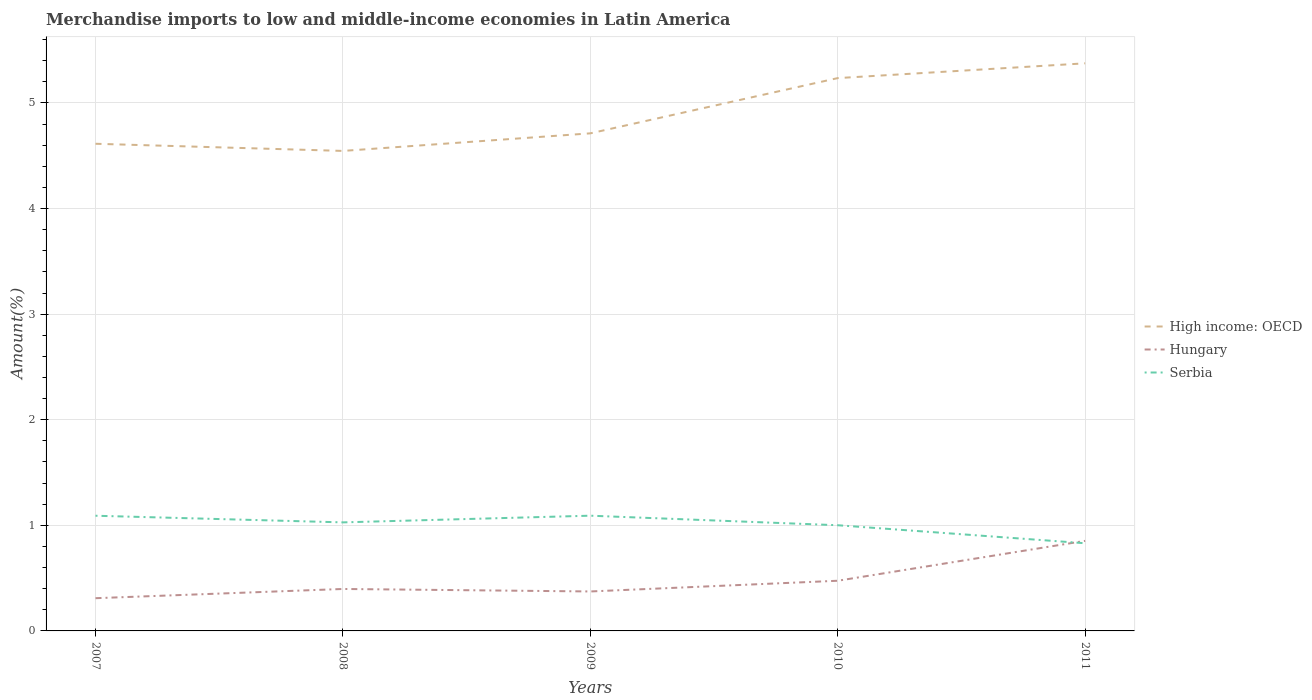How many different coloured lines are there?
Your answer should be very brief. 3. Does the line corresponding to High income: OECD intersect with the line corresponding to Serbia?
Offer a very short reply. No. Across all years, what is the maximum percentage of amount earned from merchandise imports in Serbia?
Ensure brevity in your answer.  0.83. What is the total percentage of amount earned from merchandise imports in Serbia in the graph?
Your answer should be very brief. 0.26. What is the difference between the highest and the second highest percentage of amount earned from merchandise imports in Hungary?
Make the answer very short. 0.54. What is the difference between two consecutive major ticks on the Y-axis?
Your response must be concise. 1. Does the graph contain any zero values?
Provide a short and direct response. No. Where does the legend appear in the graph?
Your response must be concise. Center right. How many legend labels are there?
Ensure brevity in your answer.  3. What is the title of the graph?
Provide a short and direct response. Merchandise imports to low and middle-income economies in Latin America. Does "Tajikistan" appear as one of the legend labels in the graph?
Your answer should be very brief. No. What is the label or title of the X-axis?
Provide a short and direct response. Years. What is the label or title of the Y-axis?
Your answer should be very brief. Amount(%). What is the Amount(%) in High income: OECD in 2007?
Make the answer very short. 4.61. What is the Amount(%) of Hungary in 2007?
Make the answer very short. 0.31. What is the Amount(%) of Serbia in 2007?
Your response must be concise. 1.09. What is the Amount(%) in High income: OECD in 2008?
Keep it short and to the point. 4.55. What is the Amount(%) in Hungary in 2008?
Keep it short and to the point. 0.4. What is the Amount(%) in Serbia in 2008?
Your answer should be compact. 1.03. What is the Amount(%) in High income: OECD in 2009?
Your answer should be compact. 4.71. What is the Amount(%) of Hungary in 2009?
Make the answer very short. 0.37. What is the Amount(%) in Serbia in 2009?
Make the answer very short. 1.09. What is the Amount(%) of High income: OECD in 2010?
Ensure brevity in your answer.  5.24. What is the Amount(%) in Hungary in 2010?
Keep it short and to the point. 0.48. What is the Amount(%) in Serbia in 2010?
Offer a very short reply. 1. What is the Amount(%) in High income: OECD in 2011?
Provide a succinct answer. 5.38. What is the Amount(%) of Hungary in 2011?
Offer a very short reply. 0.85. What is the Amount(%) of Serbia in 2011?
Offer a terse response. 0.83. Across all years, what is the maximum Amount(%) of High income: OECD?
Your response must be concise. 5.38. Across all years, what is the maximum Amount(%) in Hungary?
Offer a terse response. 0.85. Across all years, what is the maximum Amount(%) in Serbia?
Your answer should be very brief. 1.09. Across all years, what is the minimum Amount(%) of High income: OECD?
Your response must be concise. 4.55. Across all years, what is the minimum Amount(%) in Hungary?
Keep it short and to the point. 0.31. Across all years, what is the minimum Amount(%) of Serbia?
Make the answer very short. 0.83. What is the total Amount(%) in High income: OECD in the graph?
Ensure brevity in your answer.  24.48. What is the total Amount(%) in Hungary in the graph?
Your answer should be compact. 2.41. What is the total Amount(%) of Serbia in the graph?
Ensure brevity in your answer.  5.04. What is the difference between the Amount(%) of High income: OECD in 2007 and that in 2008?
Your answer should be very brief. 0.07. What is the difference between the Amount(%) of Hungary in 2007 and that in 2008?
Provide a succinct answer. -0.09. What is the difference between the Amount(%) in Serbia in 2007 and that in 2008?
Provide a short and direct response. 0.06. What is the difference between the Amount(%) in High income: OECD in 2007 and that in 2009?
Ensure brevity in your answer.  -0.1. What is the difference between the Amount(%) of Hungary in 2007 and that in 2009?
Provide a short and direct response. -0.06. What is the difference between the Amount(%) in Serbia in 2007 and that in 2009?
Offer a very short reply. -0. What is the difference between the Amount(%) of High income: OECD in 2007 and that in 2010?
Make the answer very short. -0.62. What is the difference between the Amount(%) of Hungary in 2007 and that in 2010?
Give a very brief answer. -0.17. What is the difference between the Amount(%) in Serbia in 2007 and that in 2010?
Your answer should be very brief. 0.09. What is the difference between the Amount(%) of High income: OECD in 2007 and that in 2011?
Keep it short and to the point. -0.76. What is the difference between the Amount(%) in Hungary in 2007 and that in 2011?
Your answer should be very brief. -0.54. What is the difference between the Amount(%) in Serbia in 2007 and that in 2011?
Ensure brevity in your answer.  0.26. What is the difference between the Amount(%) of High income: OECD in 2008 and that in 2009?
Offer a terse response. -0.17. What is the difference between the Amount(%) of Hungary in 2008 and that in 2009?
Provide a succinct answer. 0.02. What is the difference between the Amount(%) in Serbia in 2008 and that in 2009?
Your answer should be compact. -0.06. What is the difference between the Amount(%) of High income: OECD in 2008 and that in 2010?
Your answer should be compact. -0.69. What is the difference between the Amount(%) in Hungary in 2008 and that in 2010?
Ensure brevity in your answer.  -0.08. What is the difference between the Amount(%) of Serbia in 2008 and that in 2010?
Provide a short and direct response. 0.03. What is the difference between the Amount(%) of High income: OECD in 2008 and that in 2011?
Your answer should be very brief. -0.83. What is the difference between the Amount(%) in Hungary in 2008 and that in 2011?
Offer a terse response. -0.46. What is the difference between the Amount(%) of Serbia in 2008 and that in 2011?
Offer a terse response. 0.2. What is the difference between the Amount(%) in High income: OECD in 2009 and that in 2010?
Give a very brief answer. -0.52. What is the difference between the Amount(%) in Hungary in 2009 and that in 2010?
Keep it short and to the point. -0.1. What is the difference between the Amount(%) of Serbia in 2009 and that in 2010?
Provide a succinct answer. 0.09. What is the difference between the Amount(%) in High income: OECD in 2009 and that in 2011?
Keep it short and to the point. -0.66. What is the difference between the Amount(%) of Hungary in 2009 and that in 2011?
Provide a succinct answer. -0.48. What is the difference between the Amount(%) in Serbia in 2009 and that in 2011?
Your response must be concise. 0.26. What is the difference between the Amount(%) of High income: OECD in 2010 and that in 2011?
Offer a terse response. -0.14. What is the difference between the Amount(%) of Hungary in 2010 and that in 2011?
Provide a succinct answer. -0.38. What is the difference between the Amount(%) of Serbia in 2010 and that in 2011?
Ensure brevity in your answer.  0.17. What is the difference between the Amount(%) of High income: OECD in 2007 and the Amount(%) of Hungary in 2008?
Ensure brevity in your answer.  4.22. What is the difference between the Amount(%) in High income: OECD in 2007 and the Amount(%) in Serbia in 2008?
Provide a short and direct response. 3.59. What is the difference between the Amount(%) in Hungary in 2007 and the Amount(%) in Serbia in 2008?
Your response must be concise. -0.72. What is the difference between the Amount(%) in High income: OECD in 2007 and the Amount(%) in Hungary in 2009?
Make the answer very short. 4.24. What is the difference between the Amount(%) of High income: OECD in 2007 and the Amount(%) of Serbia in 2009?
Your answer should be very brief. 3.52. What is the difference between the Amount(%) of Hungary in 2007 and the Amount(%) of Serbia in 2009?
Provide a succinct answer. -0.78. What is the difference between the Amount(%) of High income: OECD in 2007 and the Amount(%) of Hungary in 2010?
Provide a succinct answer. 4.14. What is the difference between the Amount(%) of High income: OECD in 2007 and the Amount(%) of Serbia in 2010?
Offer a terse response. 3.61. What is the difference between the Amount(%) in Hungary in 2007 and the Amount(%) in Serbia in 2010?
Your answer should be compact. -0.69. What is the difference between the Amount(%) of High income: OECD in 2007 and the Amount(%) of Hungary in 2011?
Make the answer very short. 3.76. What is the difference between the Amount(%) of High income: OECD in 2007 and the Amount(%) of Serbia in 2011?
Offer a very short reply. 3.78. What is the difference between the Amount(%) of Hungary in 2007 and the Amount(%) of Serbia in 2011?
Give a very brief answer. -0.52. What is the difference between the Amount(%) of High income: OECD in 2008 and the Amount(%) of Hungary in 2009?
Your answer should be very brief. 4.17. What is the difference between the Amount(%) in High income: OECD in 2008 and the Amount(%) in Serbia in 2009?
Keep it short and to the point. 3.45. What is the difference between the Amount(%) of Hungary in 2008 and the Amount(%) of Serbia in 2009?
Your answer should be compact. -0.69. What is the difference between the Amount(%) of High income: OECD in 2008 and the Amount(%) of Hungary in 2010?
Provide a succinct answer. 4.07. What is the difference between the Amount(%) of High income: OECD in 2008 and the Amount(%) of Serbia in 2010?
Offer a very short reply. 3.54. What is the difference between the Amount(%) of Hungary in 2008 and the Amount(%) of Serbia in 2010?
Your answer should be very brief. -0.6. What is the difference between the Amount(%) in High income: OECD in 2008 and the Amount(%) in Hungary in 2011?
Give a very brief answer. 3.69. What is the difference between the Amount(%) in High income: OECD in 2008 and the Amount(%) in Serbia in 2011?
Offer a terse response. 3.72. What is the difference between the Amount(%) in Hungary in 2008 and the Amount(%) in Serbia in 2011?
Your answer should be very brief. -0.43. What is the difference between the Amount(%) of High income: OECD in 2009 and the Amount(%) of Hungary in 2010?
Provide a short and direct response. 4.24. What is the difference between the Amount(%) in High income: OECD in 2009 and the Amount(%) in Serbia in 2010?
Provide a short and direct response. 3.71. What is the difference between the Amount(%) in Hungary in 2009 and the Amount(%) in Serbia in 2010?
Give a very brief answer. -0.63. What is the difference between the Amount(%) of High income: OECD in 2009 and the Amount(%) of Hungary in 2011?
Offer a terse response. 3.86. What is the difference between the Amount(%) in High income: OECD in 2009 and the Amount(%) in Serbia in 2011?
Offer a terse response. 3.88. What is the difference between the Amount(%) of Hungary in 2009 and the Amount(%) of Serbia in 2011?
Provide a short and direct response. -0.46. What is the difference between the Amount(%) of High income: OECD in 2010 and the Amount(%) of Hungary in 2011?
Your answer should be very brief. 4.38. What is the difference between the Amount(%) in High income: OECD in 2010 and the Amount(%) in Serbia in 2011?
Offer a very short reply. 4.41. What is the difference between the Amount(%) in Hungary in 2010 and the Amount(%) in Serbia in 2011?
Your answer should be compact. -0.36. What is the average Amount(%) in High income: OECD per year?
Give a very brief answer. 4.9. What is the average Amount(%) in Hungary per year?
Offer a very short reply. 0.48. What is the average Amount(%) of Serbia per year?
Your answer should be very brief. 1.01. In the year 2007, what is the difference between the Amount(%) of High income: OECD and Amount(%) of Hungary?
Provide a succinct answer. 4.3. In the year 2007, what is the difference between the Amount(%) of High income: OECD and Amount(%) of Serbia?
Give a very brief answer. 3.52. In the year 2007, what is the difference between the Amount(%) of Hungary and Amount(%) of Serbia?
Your response must be concise. -0.78. In the year 2008, what is the difference between the Amount(%) of High income: OECD and Amount(%) of Hungary?
Make the answer very short. 4.15. In the year 2008, what is the difference between the Amount(%) of High income: OECD and Amount(%) of Serbia?
Make the answer very short. 3.52. In the year 2008, what is the difference between the Amount(%) in Hungary and Amount(%) in Serbia?
Make the answer very short. -0.63. In the year 2009, what is the difference between the Amount(%) in High income: OECD and Amount(%) in Hungary?
Your response must be concise. 4.34. In the year 2009, what is the difference between the Amount(%) in High income: OECD and Amount(%) in Serbia?
Make the answer very short. 3.62. In the year 2009, what is the difference between the Amount(%) of Hungary and Amount(%) of Serbia?
Offer a terse response. -0.72. In the year 2010, what is the difference between the Amount(%) in High income: OECD and Amount(%) in Hungary?
Offer a very short reply. 4.76. In the year 2010, what is the difference between the Amount(%) in High income: OECD and Amount(%) in Serbia?
Your answer should be compact. 4.23. In the year 2010, what is the difference between the Amount(%) of Hungary and Amount(%) of Serbia?
Provide a short and direct response. -0.53. In the year 2011, what is the difference between the Amount(%) in High income: OECD and Amount(%) in Hungary?
Your answer should be compact. 4.52. In the year 2011, what is the difference between the Amount(%) in High income: OECD and Amount(%) in Serbia?
Keep it short and to the point. 4.55. In the year 2011, what is the difference between the Amount(%) of Hungary and Amount(%) of Serbia?
Ensure brevity in your answer.  0.02. What is the ratio of the Amount(%) of High income: OECD in 2007 to that in 2008?
Your answer should be very brief. 1.01. What is the ratio of the Amount(%) of Hungary in 2007 to that in 2008?
Provide a succinct answer. 0.78. What is the ratio of the Amount(%) in Serbia in 2007 to that in 2008?
Your answer should be compact. 1.06. What is the ratio of the Amount(%) of High income: OECD in 2007 to that in 2009?
Offer a very short reply. 0.98. What is the ratio of the Amount(%) in Hungary in 2007 to that in 2009?
Make the answer very short. 0.83. What is the ratio of the Amount(%) of High income: OECD in 2007 to that in 2010?
Provide a short and direct response. 0.88. What is the ratio of the Amount(%) in Hungary in 2007 to that in 2010?
Provide a short and direct response. 0.65. What is the ratio of the Amount(%) in Serbia in 2007 to that in 2010?
Offer a very short reply. 1.09. What is the ratio of the Amount(%) in High income: OECD in 2007 to that in 2011?
Your answer should be compact. 0.86. What is the ratio of the Amount(%) in Hungary in 2007 to that in 2011?
Keep it short and to the point. 0.36. What is the ratio of the Amount(%) in Serbia in 2007 to that in 2011?
Your response must be concise. 1.31. What is the ratio of the Amount(%) of High income: OECD in 2008 to that in 2009?
Your response must be concise. 0.96. What is the ratio of the Amount(%) in Hungary in 2008 to that in 2009?
Provide a short and direct response. 1.06. What is the ratio of the Amount(%) in Serbia in 2008 to that in 2009?
Your answer should be very brief. 0.94. What is the ratio of the Amount(%) in High income: OECD in 2008 to that in 2010?
Your response must be concise. 0.87. What is the ratio of the Amount(%) of Hungary in 2008 to that in 2010?
Provide a short and direct response. 0.84. What is the ratio of the Amount(%) of Serbia in 2008 to that in 2010?
Offer a very short reply. 1.03. What is the ratio of the Amount(%) in High income: OECD in 2008 to that in 2011?
Offer a very short reply. 0.85. What is the ratio of the Amount(%) of Hungary in 2008 to that in 2011?
Provide a short and direct response. 0.47. What is the ratio of the Amount(%) in Serbia in 2008 to that in 2011?
Provide a short and direct response. 1.24. What is the ratio of the Amount(%) in High income: OECD in 2009 to that in 2010?
Your response must be concise. 0.9. What is the ratio of the Amount(%) in Hungary in 2009 to that in 2010?
Your answer should be very brief. 0.79. What is the ratio of the Amount(%) of Serbia in 2009 to that in 2010?
Give a very brief answer. 1.09. What is the ratio of the Amount(%) of High income: OECD in 2009 to that in 2011?
Make the answer very short. 0.88. What is the ratio of the Amount(%) in Hungary in 2009 to that in 2011?
Ensure brevity in your answer.  0.44. What is the ratio of the Amount(%) in Serbia in 2009 to that in 2011?
Keep it short and to the point. 1.31. What is the ratio of the Amount(%) of High income: OECD in 2010 to that in 2011?
Provide a succinct answer. 0.97. What is the ratio of the Amount(%) in Hungary in 2010 to that in 2011?
Give a very brief answer. 0.56. What is the ratio of the Amount(%) in Serbia in 2010 to that in 2011?
Provide a succinct answer. 1.21. What is the difference between the highest and the second highest Amount(%) in High income: OECD?
Give a very brief answer. 0.14. What is the difference between the highest and the second highest Amount(%) of Hungary?
Offer a very short reply. 0.38. What is the difference between the highest and the second highest Amount(%) in Serbia?
Offer a very short reply. 0. What is the difference between the highest and the lowest Amount(%) in High income: OECD?
Give a very brief answer. 0.83. What is the difference between the highest and the lowest Amount(%) in Hungary?
Offer a terse response. 0.54. What is the difference between the highest and the lowest Amount(%) in Serbia?
Provide a short and direct response. 0.26. 